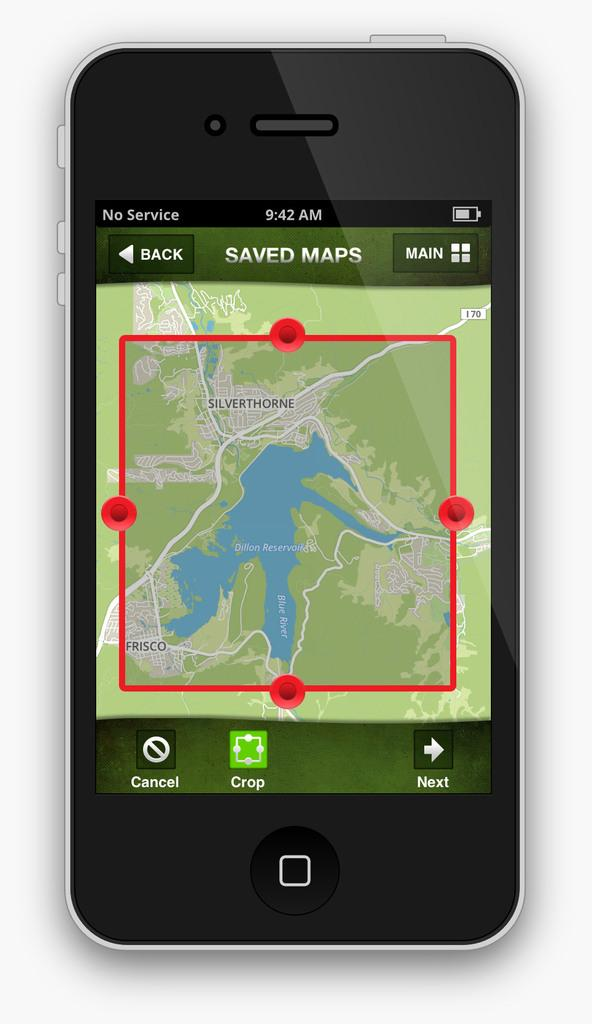<image>
Give a short and clear explanation of the subsequent image. An electronic device open to a page that says Saved Maps. 